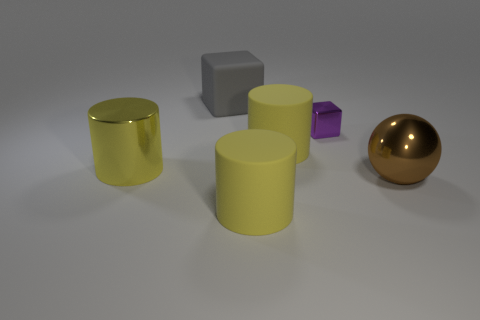Is the shape of the gray thing the same as the tiny object? No, the shape of the gray object, which is a cube, is not the same as that of the tiny object. The tiny object appears to be a purple cube, and while both objects are cubic, their sizes differ significantly. Moreover, the reflective properties and colors of the two objects also vary, with the gray cube having a matte finish and a neutral color, while the tiny purple cube has a somewhat shiny surface. 